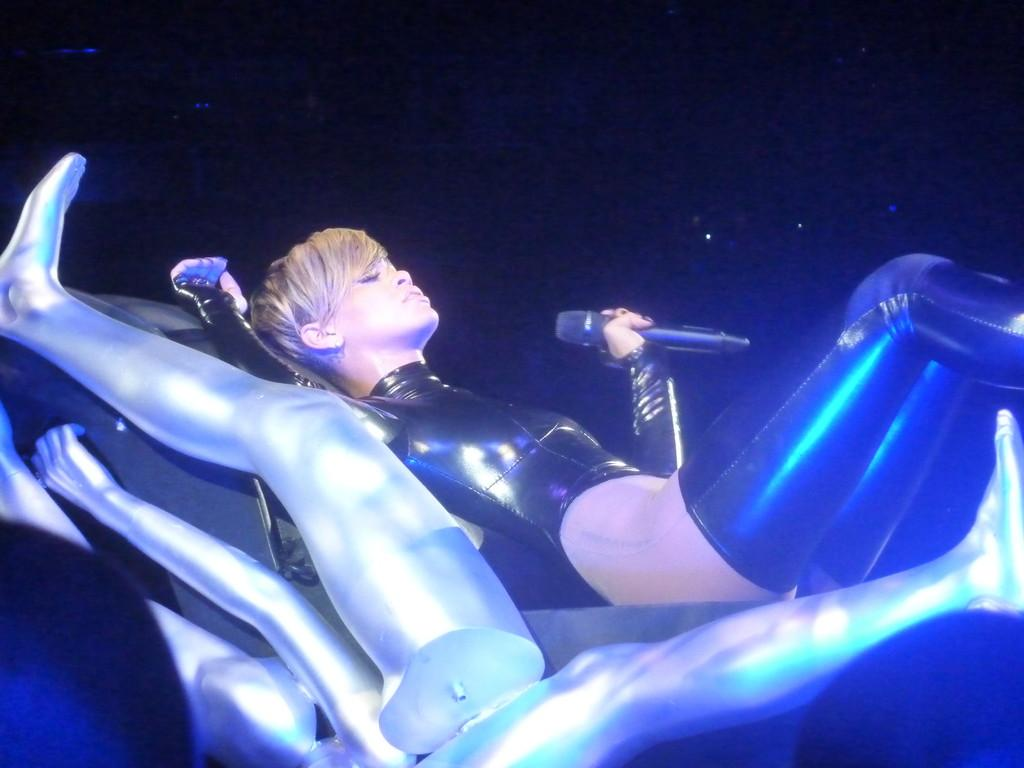What is the person in the image doing? The person is lying on a surface and holding a mic. What objects in the image resemble human body parts? There are silver-colored objects in the image that resemble human hands and legs. How many visitors can be seen in the image? There are no visitors present in the image. Is there a sink visible in the image? There is no sink present in the image. 